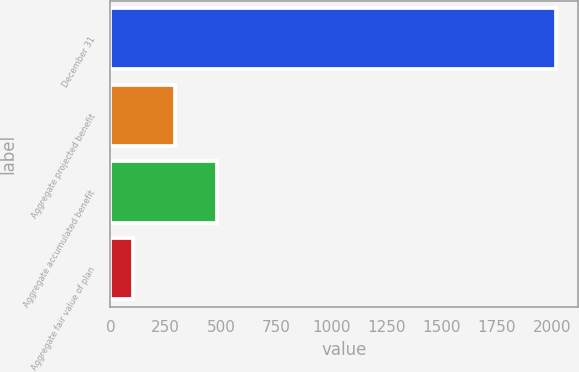Convert chart to OTSL. <chart><loc_0><loc_0><loc_500><loc_500><bar_chart><fcel>December 31<fcel>Aggregate projected benefit<fcel>Aggregate accumulated benefit<fcel>Aggregate fair value of plan<nl><fcel>2015<fcel>292.49<fcel>483.88<fcel>101.1<nl></chart> 